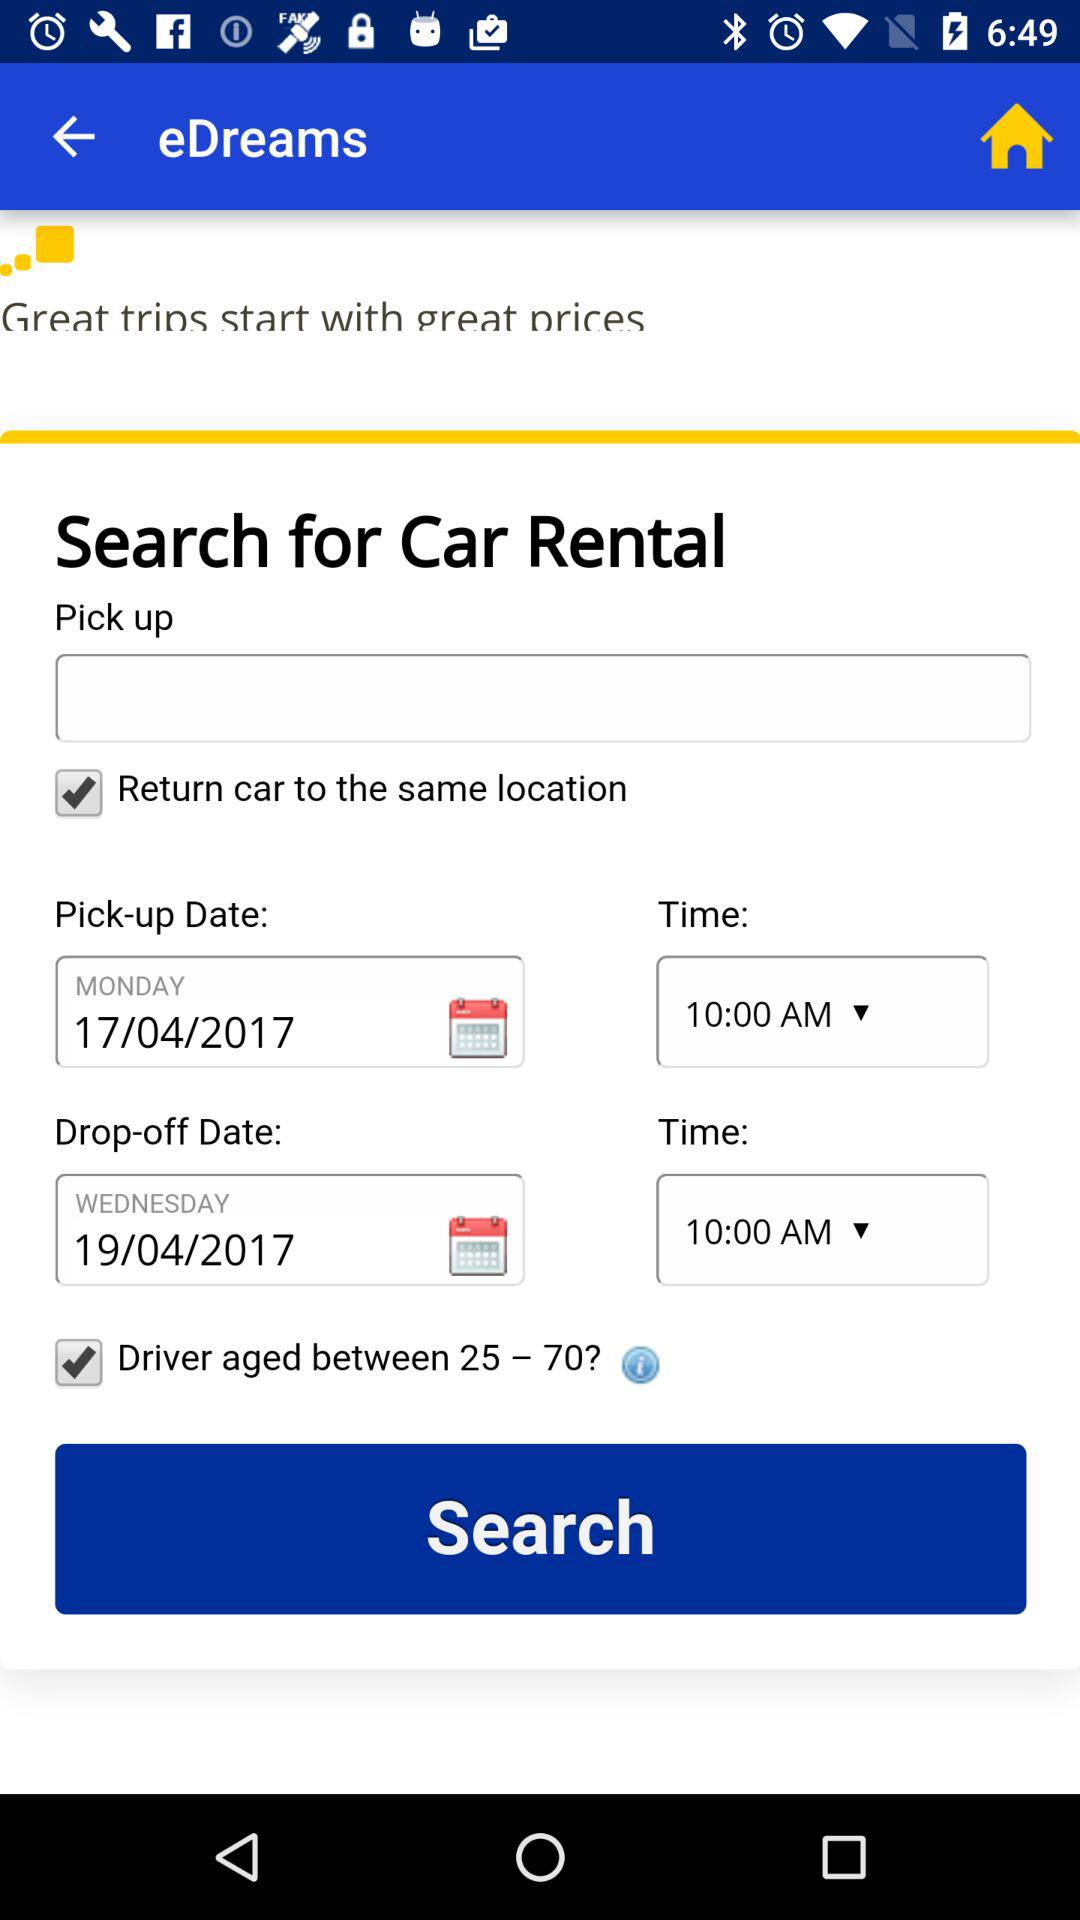What is the minimum age of the driver?
Answer the question using a single word or phrase. 25 